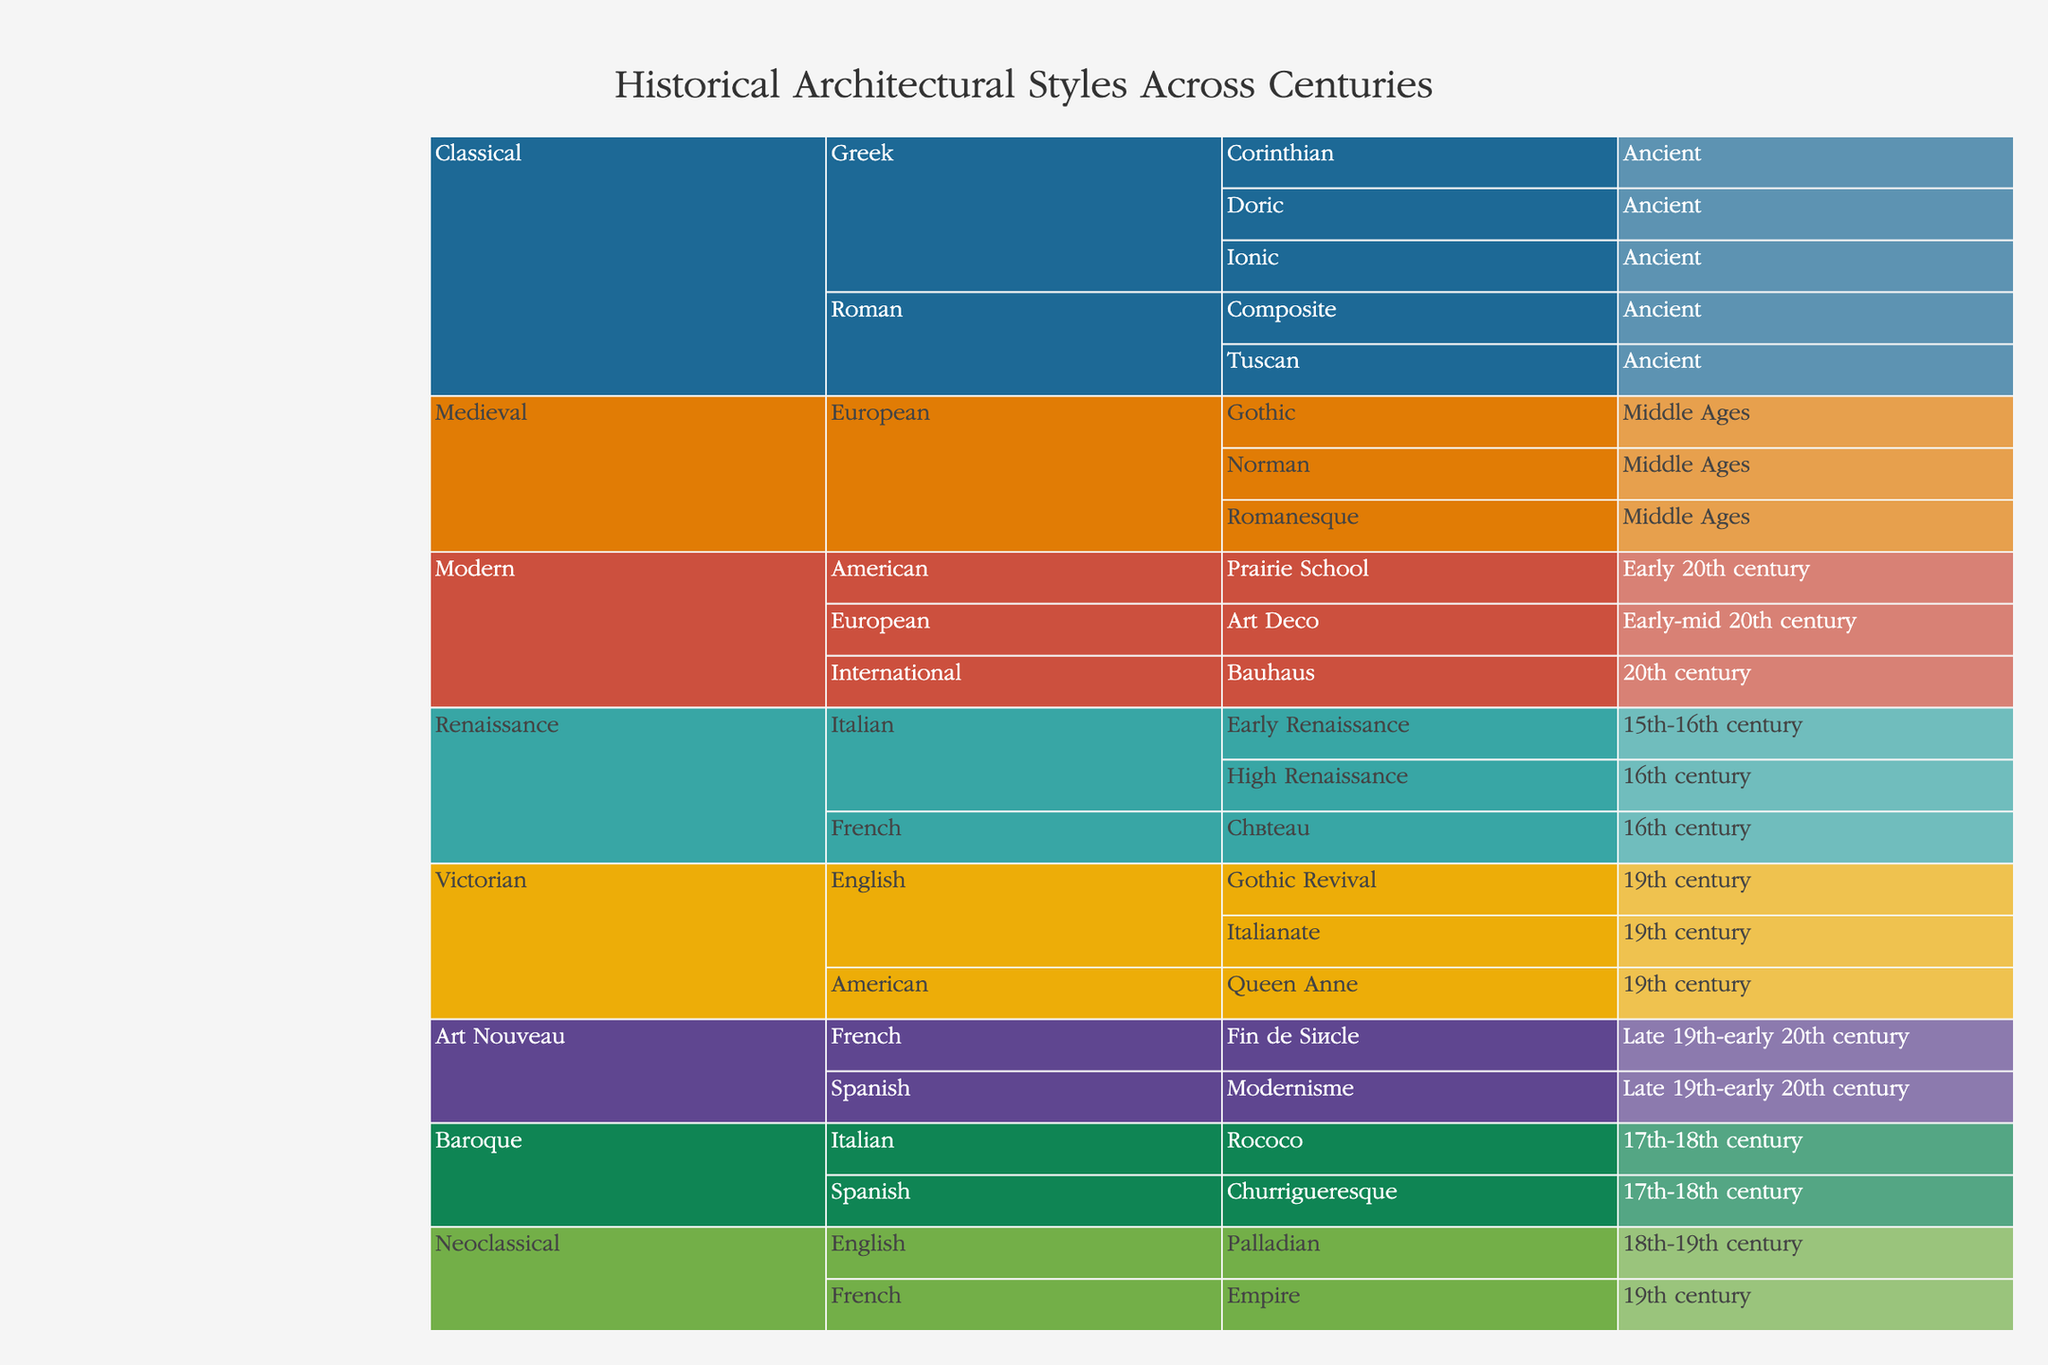What's the title of the figure? The title is usually placed prominently at the top of the figure. In this case, you can observe at the top of the icicle chart that the title reads "Historical Architectural Styles Across Centuries."
Answer: Historical Architectural Styles Across Centuries Which region has the earliest architectural styles represented in the chart? To find this, look for the region under the overarching category with styles labeled as "Ancient." The Greek and Roman sub-styles fall under the Ancient era, making these the earliest represented.
Answer: Greek and Roman How many eras are listed for the Classical architectural style? Within the Classical architectural style category, count the unique eras for the sub-styles. The sub-styles (Doric, Ionic, Corinthian, Tuscan, Composite) all fall under the "Ancient" era, thus only one era is represented.
Answer: 1 Compare the number of sub-styles between the Medieval and Victorian architectural styles. Which has more? Examine each category to count the number of sub-styles listed under Medieval (Romanesque, Gothic, Norman) and Victorian (Gothic Revival, Italianate, Queen Anne).
Answer: Victorian Identify an architectural style from the 20th century represented in the chart. Locate the time periods and architectural styles listed under the 20th century. Modern styles such as Bauhaus, Prairie School, and Art Deco appear in this era.
Answer: Bauhaus Which architectural style includes the "Norman" sub-style and in which era is it categorized? Find the "Norman" sub-style in the icicle chart and check its corresponding architectural style and era. It falls under Medieval and the Middle Ages era.
Answer: Medieval, Middle Ages How does the number of sub-styles in the Italian Renaissance compare to the French Renaissance? Count the sub-styles under both the Italian Renaissance (Early Renaissance, High Renaissance) and the French Renaissance (Château).
Answer: Italian Renaissance has more Which architectural style includes "Modernisme" as a sub-style? Search for the sub-style "Modernisme" on the icicle chart and identify its associated architectural style. It falls under Art Nouveau.
Answer: Art Nouveau 